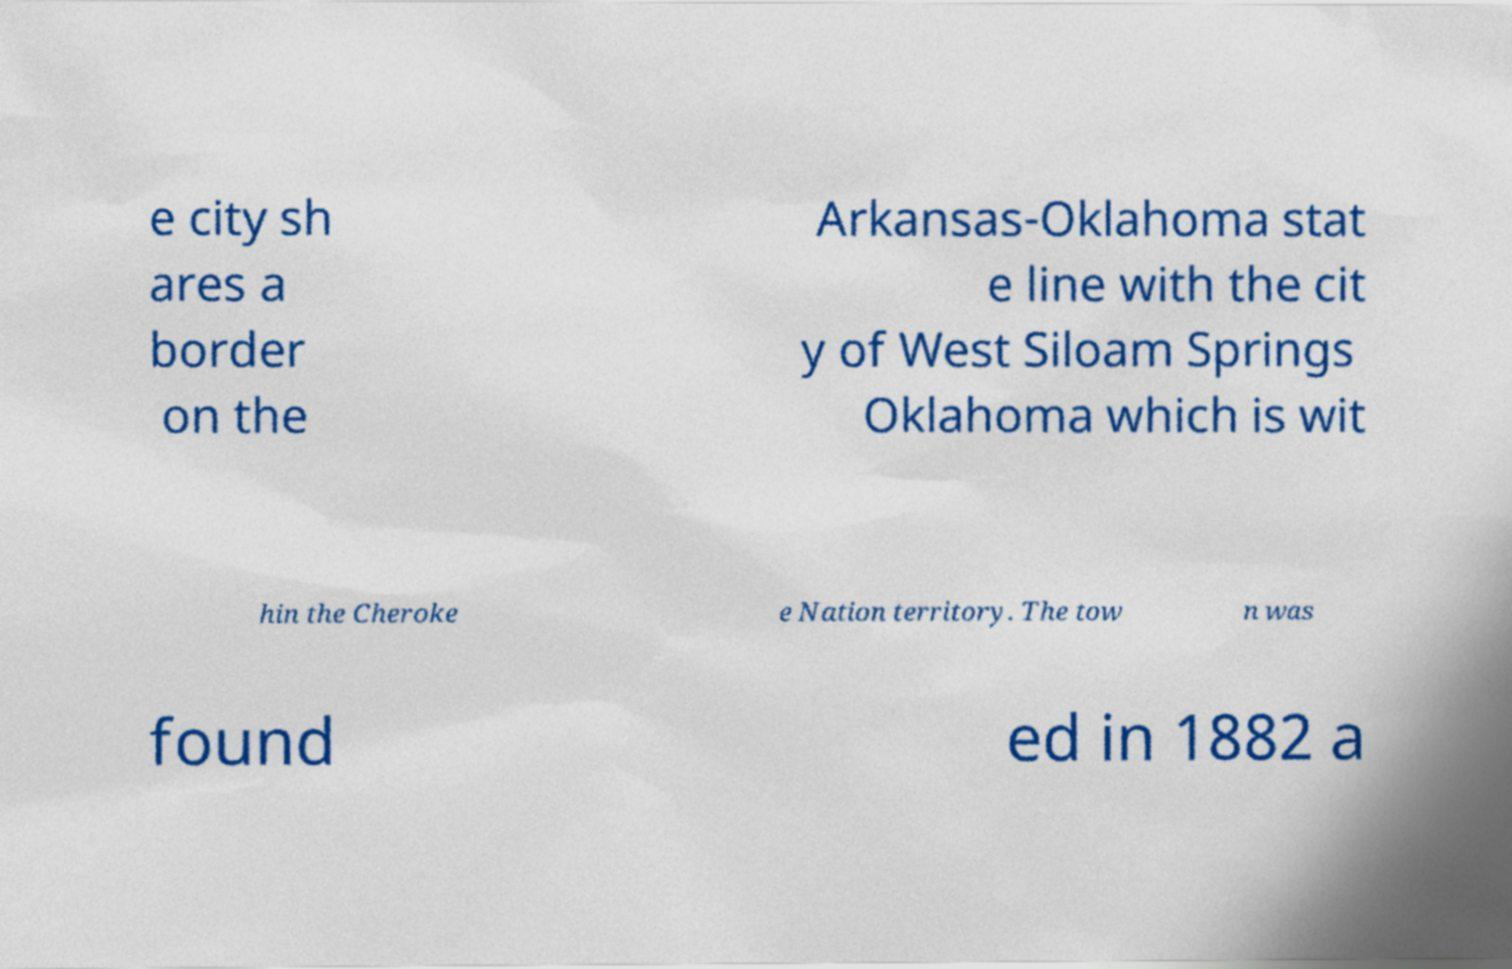Please read and relay the text visible in this image. What does it say? e city sh ares a border on the Arkansas-Oklahoma stat e line with the cit y of West Siloam Springs Oklahoma which is wit hin the Cheroke e Nation territory. The tow n was found ed in 1882 a 